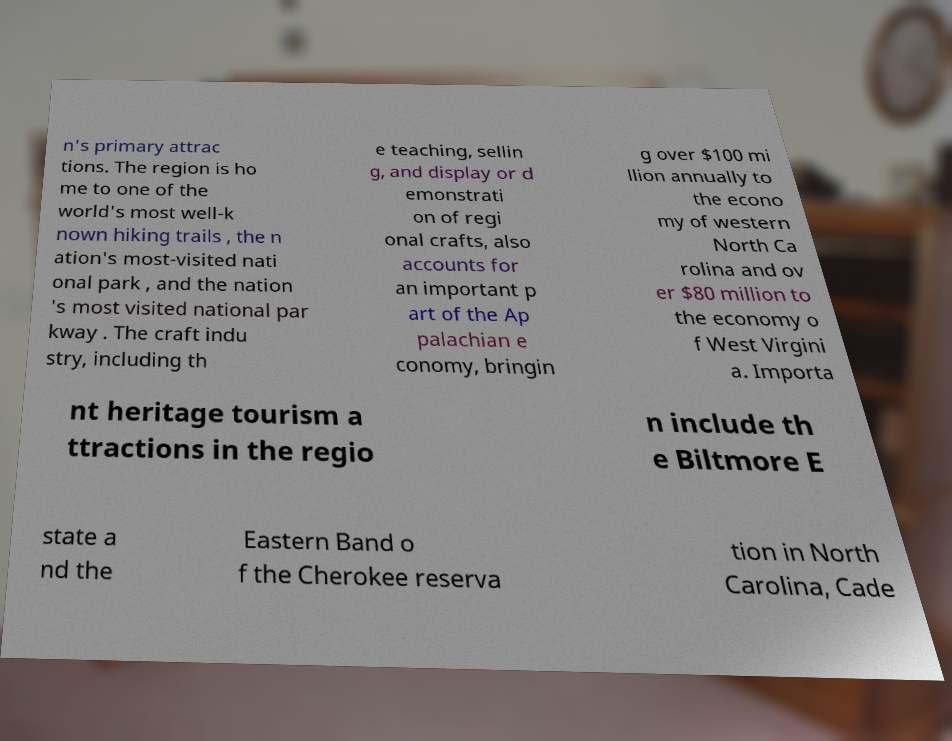Could you extract and type out the text from this image? n's primary attrac tions. The region is ho me to one of the world's most well-k nown hiking trails , the n ation's most-visited nati onal park , and the nation 's most visited national par kway . The craft indu stry, including th e teaching, sellin g, and display or d emonstrati on of regi onal crafts, also accounts for an important p art of the Ap palachian e conomy, bringin g over $100 mi llion annually to the econo my of western North Ca rolina and ov er $80 million to the economy o f West Virgini a. Importa nt heritage tourism a ttractions in the regio n include th e Biltmore E state a nd the Eastern Band o f the Cherokee reserva tion in North Carolina, Cade 